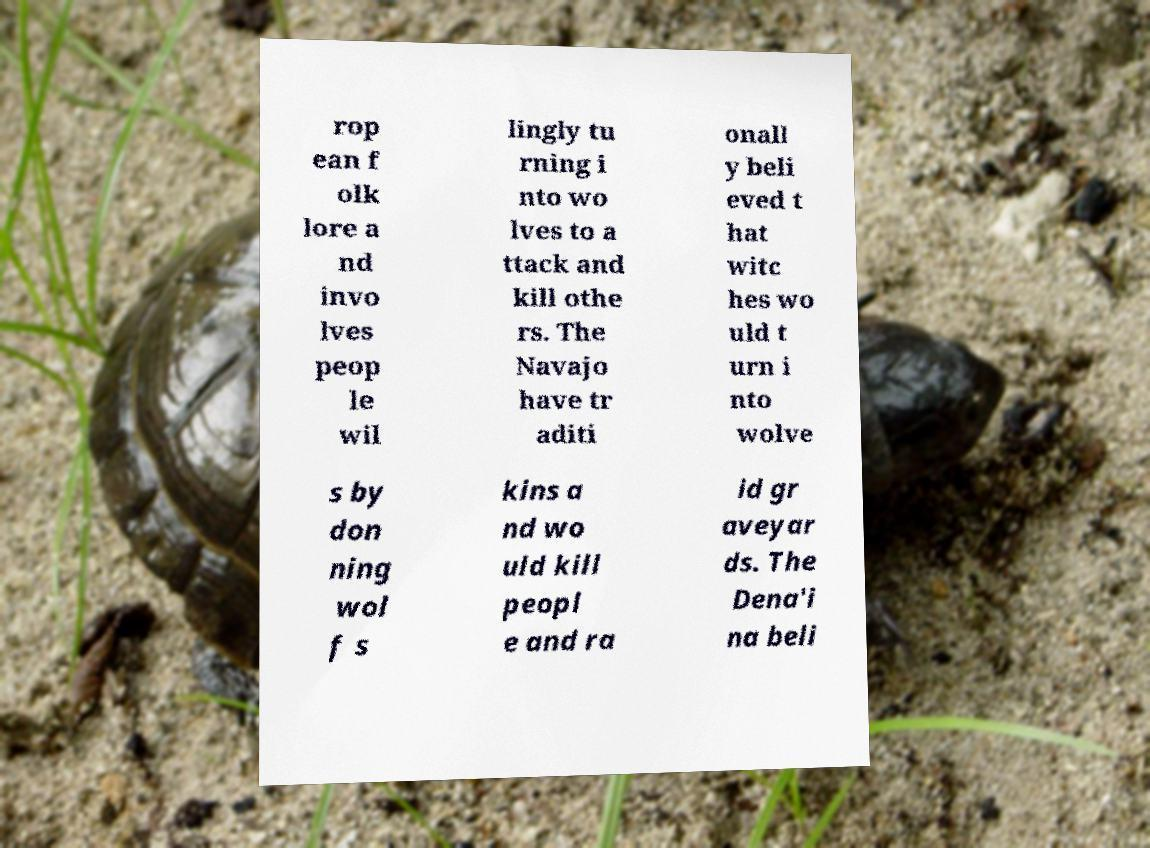Could you assist in decoding the text presented in this image and type it out clearly? rop ean f olk lore a nd invo lves peop le wil lingly tu rning i nto wo lves to a ttack and kill othe rs. The Navajo have tr aditi onall y beli eved t hat witc hes wo uld t urn i nto wolve s by don ning wol f s kins a nd wo uld kill peopl e and ra id gr aveyar ds. The Dena'i na beli 